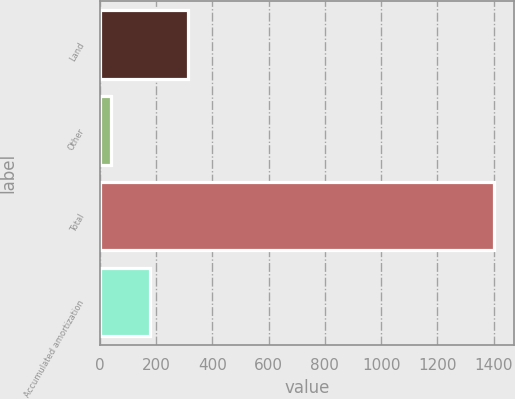<chart> <loc_0><loc_0><loc_500><loc_500><bar_chart><fcel>Land<fcel>Other<fcel>Total<fcel>Accumulated amortization<nl><fcel>313.28<fcel>41.2<fcel>1401.6<fcel>177.24<nl></chart> 